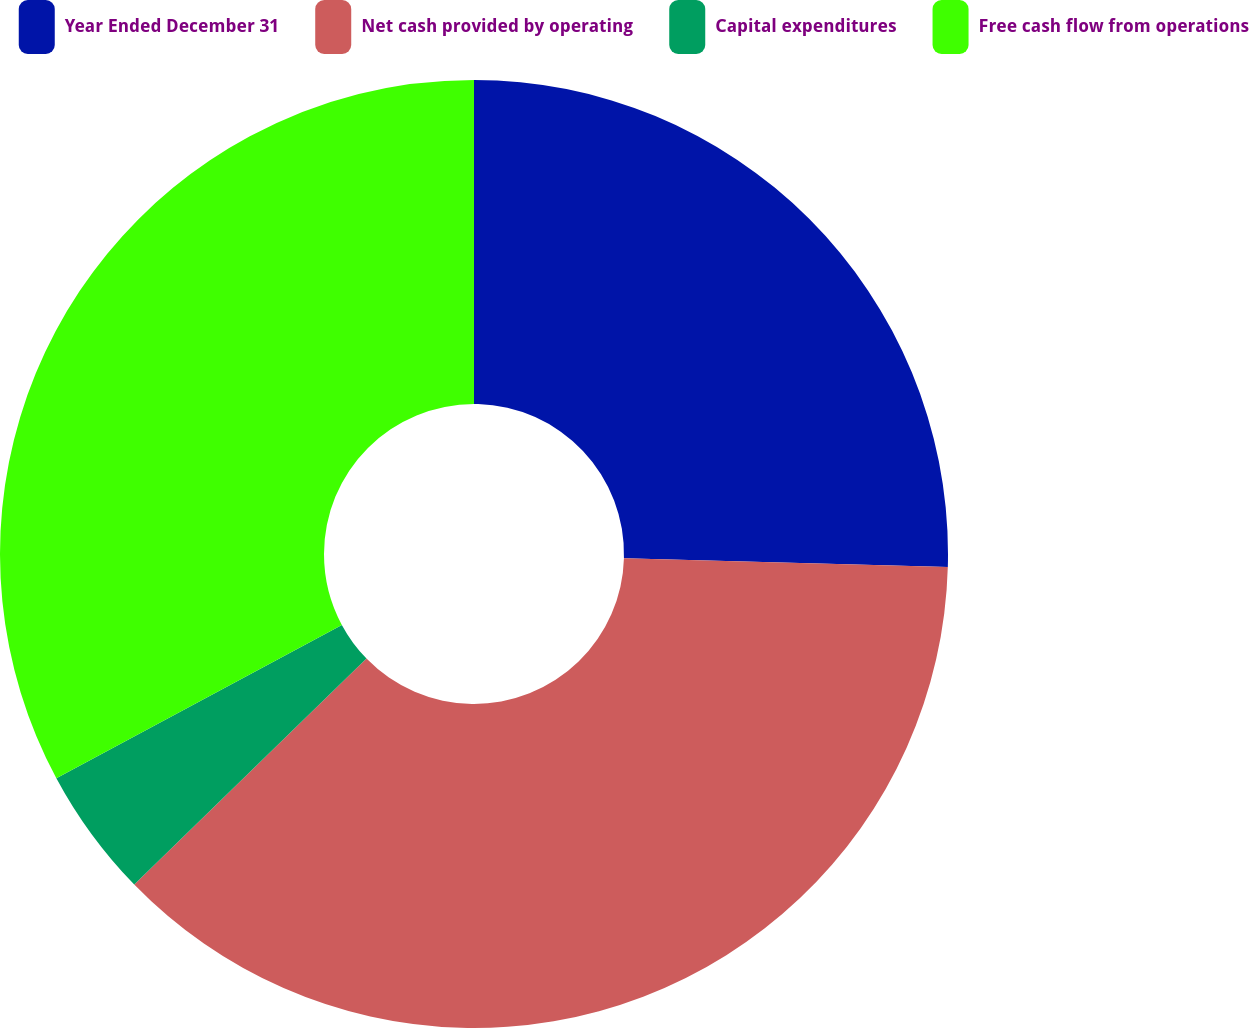<chart> <loc_0><loc_0><loc_500><loc_500><pie_chart><fcel>Year Ended December 31<fcel>Net cash provided by operating<fcel>Capital expenditures<fcel>Free cash flow from operations<nl><fcel>25.44%<fcel>37.28%<fcel>4.44%<fcel>32.84%<nl></chart> 